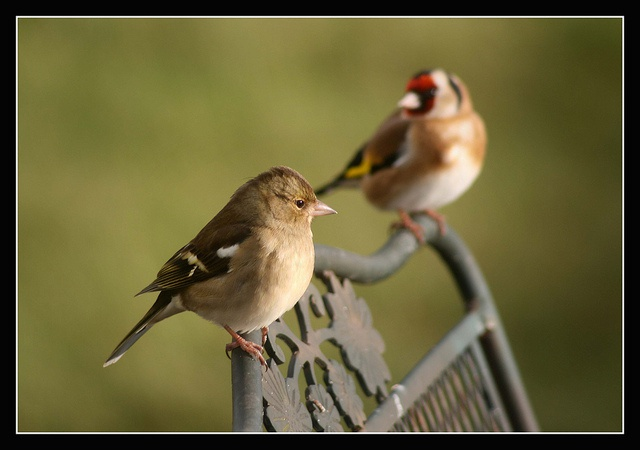Describe the objects in this image and their specific colors. I can see chair in black, olive, gray, and darkgray tones, bird in black, maroon, and tan tones, and bird in black, maroon, and gray tones in this image. 